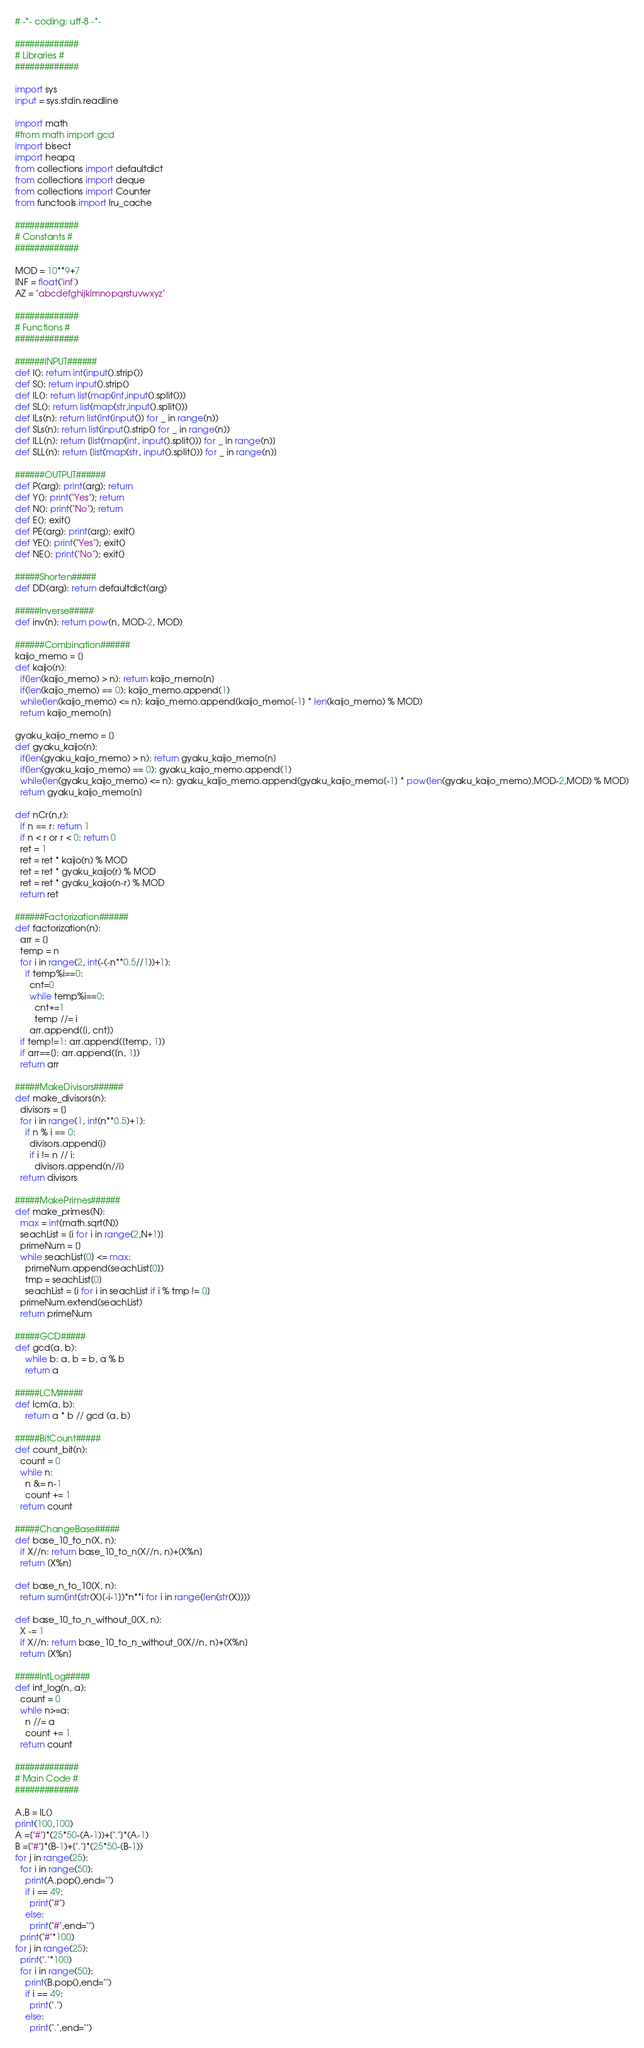<code> <loc_0><loc_0><loc_500><loc_500><_Python_># -*- coding: utf-8 -*-

#############
# Libraries #
#############

import sys
input = sys.stdin.readline

import math
#from math import gcd
import bisect
import heapq
from collections import defaultdict
from collections import deque
from collections import Counter
from functools import lru_cache

#############
# Constants #
#############

MOD = 10**9+7
INF = float('inf')
AZ = "abcdefghijklmnopqrstuvwxyz"

#############
# Functions #
#############

######INPUT######
def I(): return int(input().strip())
def S(): return input().strip()
def IL(): return list(map(int,input().split()))
def SL(): return list(map(str,input().split()))
def ILs(n): return list(int(input()) for _ in range(n))
def SLs(n): return list(input().strip() for _ in range(n))
def ILL(n): return [list(map(int, input().split())) for _ in range(n)]
def SLL(n): return [list(map(str, input().split())) for _ in range(n)]

######OUTPUT######
def P(arg): print(arg); return
def Y(): print("Yes"); return
def N(): print("No"); return
def E(): exit()
def PE(arg): print(arg); exit()
def YE(): print("Yes"); exit()
def NE(): print("No"); exit()

#####Shorten#####
def DD(arg): return defaultdict(arg)

#####Inverse#####
def inv(n): return pow(n, MOD-2, MOD)

######Combination######
kaijo_memo = []
def kaijo(n):
  if(len(kaijo_memo) > n): return kaijo_memo[n]
  if(len(kaijo_memo) == 0): kaijo_memo.append(1)
  while(len(kaijo_memo) <= n): kaijo_memo.append(kaijo_memo[-1] * len(kaijo_memo) % MOD)
  return kaijo_memo[n]

gyaku_kaijo_memo = []
def gyaku_kaijo(n):
  if(len(gyaku_kaijo_memo) > n): return gyaku_kaijo_memo[n]
  if(len(gyaku_kaijo_memo) == 0): gyaku_kaijo_memo.append(1)
  while(len(gyaku_kaijo_memo) <= n): gyaku_kaijo_memo.append(gyaku_kaijo_memo[-1] * pow(len(gyaku_kaijo_memo),MOD-2,MOD) % MOD)
  return gyaku_kaijo_memo[n]

def nCr(n,r):
  if n == r: return 1
  if n < r or r < 0: return 0
  ret = 1
  ret = ret * kaijo(n) % MOD
  ret = ret * gyaku_kaijo(r) % MOD
  ret = ret * gyaku_kaijo(n-r) % MOD
  return ret

######Factorization######
def factorization(n):
  arr = []
  temp = n
  for i in range(2, int(-(-n**0.5//1))+1):
    if temp%i==0:
      cnt=0
      while temp%i==0: 
        cnt+=1 
        temp //= i
      arr.append([i, cnt])
  if temp!=1: arr.append([temp, 1])
  if arr==[]: arr.append([n, 1])
  return arr

#####MakeDivisors######
def make_divisors(n):
  divisors = []
  for i in range(1, int(n**0.5)+1):
    if n % i == 0:
      divisors.append(i)
      if i != n // i: 
        divisors.append(n//i)
  return divisors

#####MakePrimes######
def make_primes(N):
  max = int(math.sqrt(N))
  seachList = [i for i in range(2,N+1)]
  primeNum = []
  while seachList[0] <= max:
    primeNum.append(seachList[0])
    tmp = seachList[0]
    seachList = [i for i in seachList if i % tmp != 0]
  primeNum.extend(seachList)
  return primeNum

#####GCD#####
def gcd(a, b):
    while b: a, b = b, a % b
    return a

#####LCM#####
def lcm(a, b):
    return a * b // gcd (a, b)

#####BitCount#####
def count_bit(n):
  count = 0
  while n:
    n &= n-1
    count += 1
  return count

#####ChangeBase#####
def base_10_to_n(X, n):
  if X//n: return base_10_to_n(X//n, n)+[X%n]
  return [X%n]

def base_n_to_10(X, n):
  return sum(int(str(X)[-i-1])*n**i for i in range(len(str(X))))

def base_10_to_n_without_0(X, n):
  X -= 1
  if X//n: return base_10_to_n_without_0(X//n, n)+[X%n]
  return [X%n]

#####IntLog#####
def int_log(n, a):
  count = 0
  while n>=a:
    n //= a
    count += 1
  return count

#############
# Main Code #
#############

A,B = IL()
print(100,100)
A =["#"]*(25*50-(A-1))+["."]*(A-1) 
B =["#"]*(B-1)+["."]*(25*50-(B-1))
for j in range(25):
  for i in range(50):
    print(A.pop(),end="")
    if i == 49:
      print("#")
    else:
      print("#",end="")
  print("#"*100)
for j in range(25):
  print("."*100)
  for i in range(50):
    print(B.pop(),end="")
    if i == 49:
      print(".")
    else:
      print(".",end="")</code> 